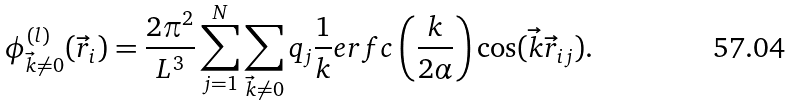<formula> <loc_0><loc_0><loc_500><loc_500>\phi _ { \vec { k } \neq 0 } ^ { ( l ) } ( \vec { r } _ { i } ) = \frac { 2 \pi ^ { 2 } } { L ^ { 3 } } \sum _ { j = 1 } ^ { N } \sum _ { \vec { k } \neq 0 } q _ { j } \frac { 1 } { k } e r f c \left ( \frac { k } { 2 \alpha } \right ) \cos ( \vec { k } \vec { r } _ { i j } ) .</formula> 